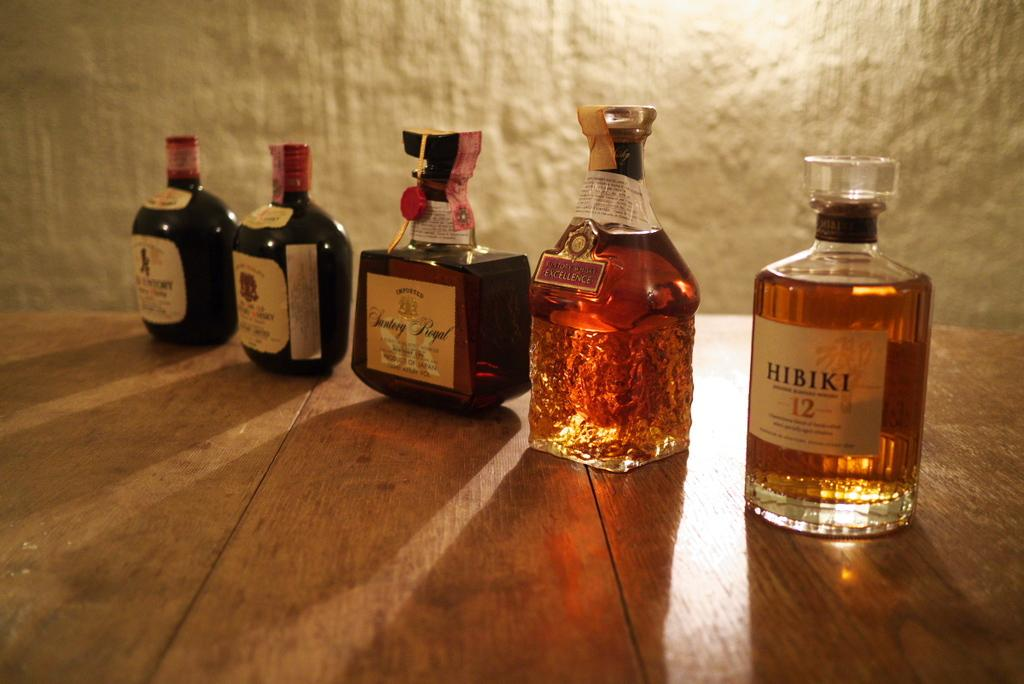Where was the image taken? The image is taken indoors. What can be seen on the table in the image? There are bottles of wine on the table. What is visible in the background of the image? There is a wall in the background of the image. What degree is being advertised on the wall in the image? There is no advertisement or degree present in the image; it only features a wall in the background. 